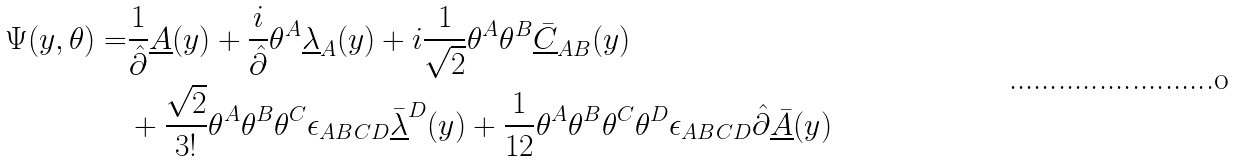Convert formula to latex. <formula><loc_0><loc_0><loc_500><loc_500>\Psi ( y , \theta ) = & \frac { 1 } { \hat { \partial } } \underline { A } ( y ) + \frac { i } { \hat { \partial } } \theta ^ { A } \underline { \lambda } _ { A } ( y ) + i \frac { 1 } { \sqrt { 2 } } \theta ^ { A } \theta ^ { B } \underline { \bar { C } } _ { A B } ( y ) \\ & + \frac { \sqrt { 2 } } { 3 ! } \theta ^ { A } \theta ^ { B } \theta ^ { C } \epsilon _ { A B C D } \underline { \bar { \lambda } } ^ { D } ( y ) + \frac { 1 } { 1 2 } \theta ^ { A } \theta ^ { B } \theta ^ { C } \theta ^ { D } \epsilon _ { A B C D } \hat { \partial } \underline { \bar { A } } ( y )</formula> 